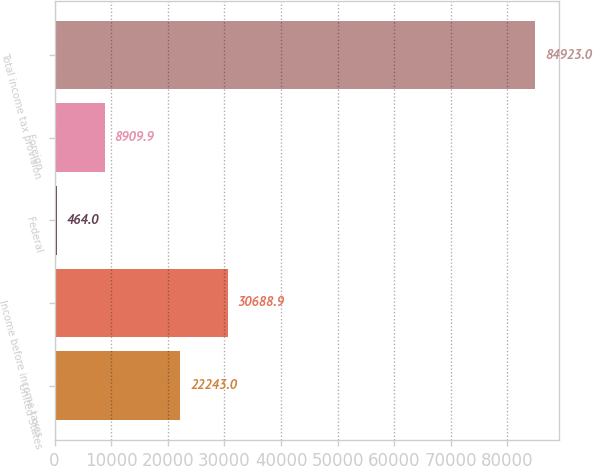Convert chart. <chart><loc_0><loc_0><loc_500><loc_500><bar_chart><fcel>United States<fcel>Income before income taxes<fcel>Federal<fcel>Foreign<fcel>Total income tax provision<nl><fcel>22243<fcel>30688.9<fcel>464<fcel>8909.9<fcel>84923<nl></chart> 